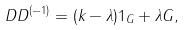Convert formula to latex. <formula><loc_0><loc_0><loc_500><loc_500>D D ^ { ( - 1 ) } = ( k - \lambda ) 1 _ { G } + \lambda G ,</formula> 